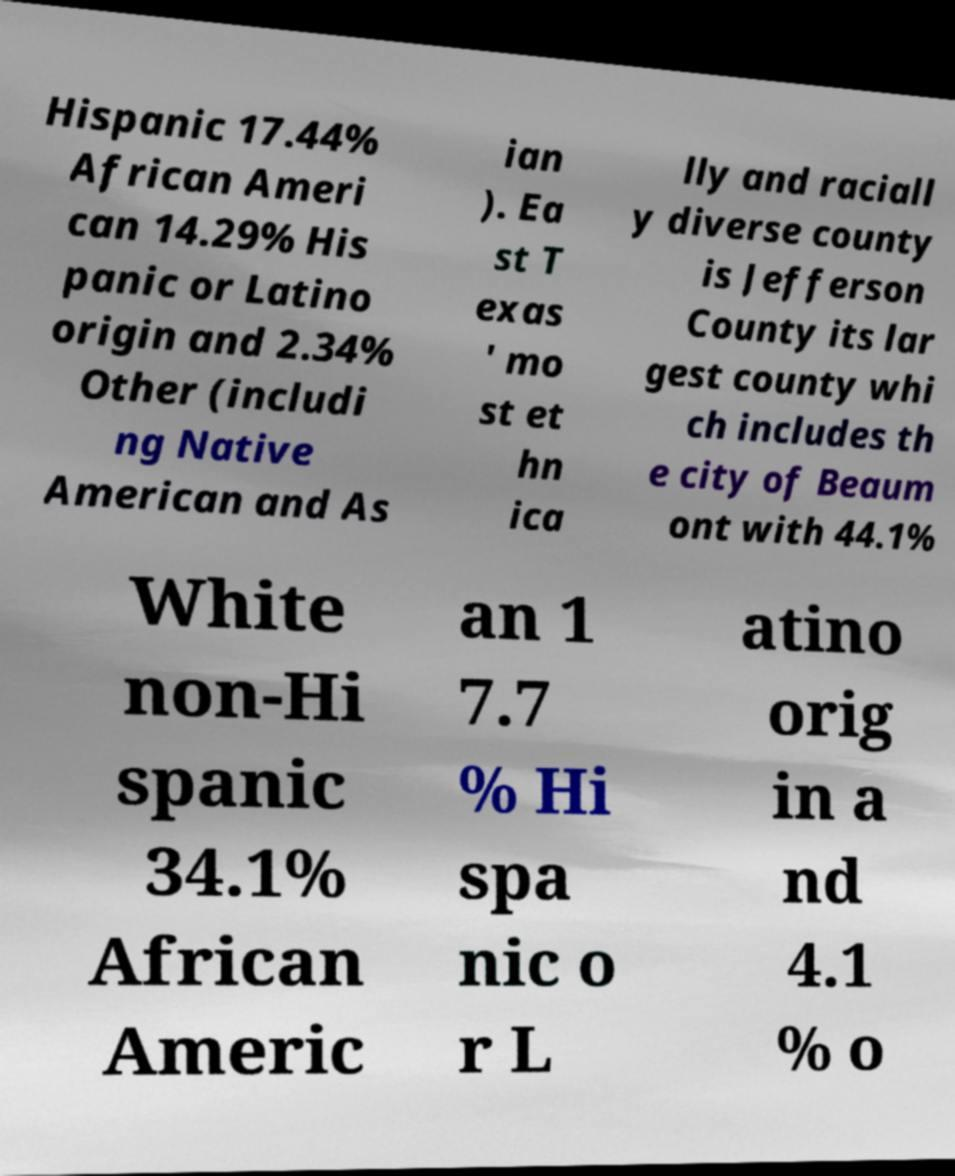Could you extract and type out the text from this image? Hispanic 17.44% African Ameri can 14.29% His panic or Latino origin and 2.34% Other (includi ng Native American and As ian ). Ea st T exas ' mo st et hn ica lly and raciall y diverse county is Jefferson County its lar gest county whi ch includes th e city of Beaum ont with 44.1% White non-Hi spanic 34.1% African Americ an 1 7.7 % Hi spa nic o r L atino orig in a nd 4.1 % o 